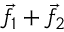Convert formula to latex. <formula><loc_0><loc_0><loc_500><loc_500>{ \vec { f } } _ { 1 } + { \vec { f } } _ { 2 }</formula> 